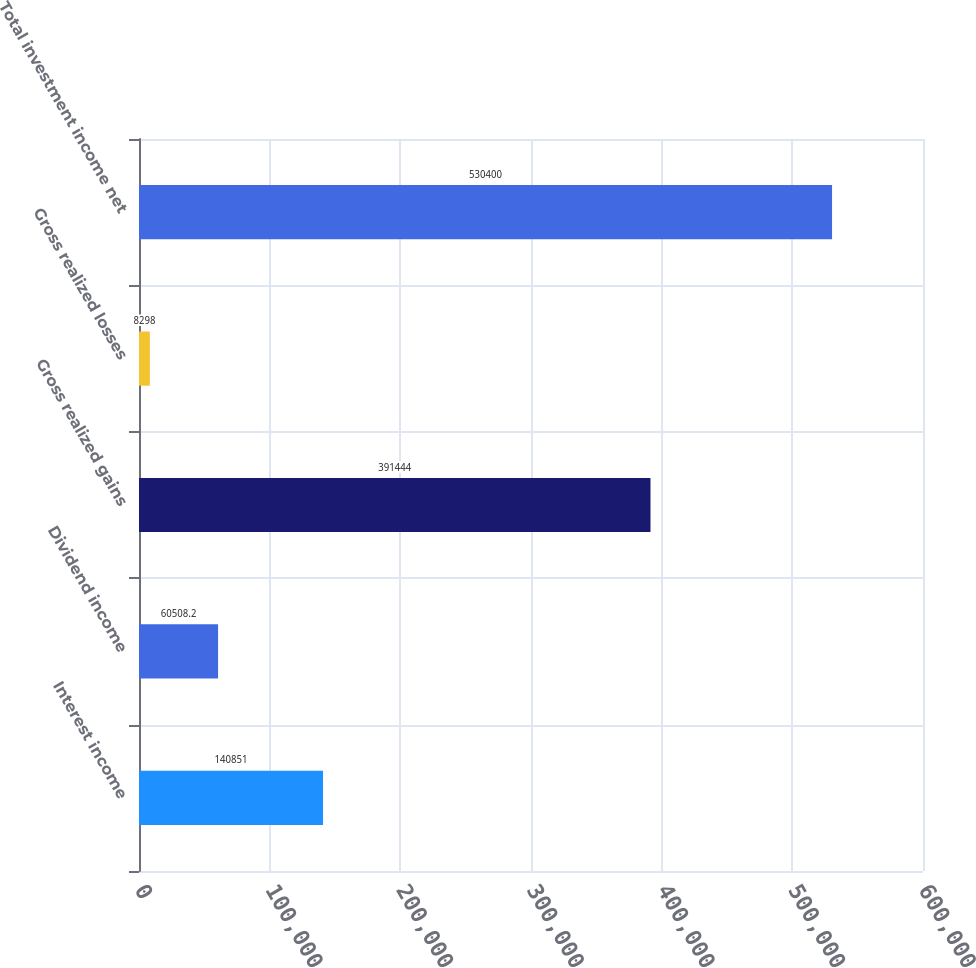Convert chart. <chart><loc_0><loc_0><loc_500><loc_500><bar_chart><fcel>Interest income<fcel>Dividend income<fcel>Gross realized gains<fcel>Gross realized losses<fcel>Total investment income net<nl><fcel>140851<fcel>60508.2<fcel>391444<fcel>8298<fcel>530400<nl></chart> 